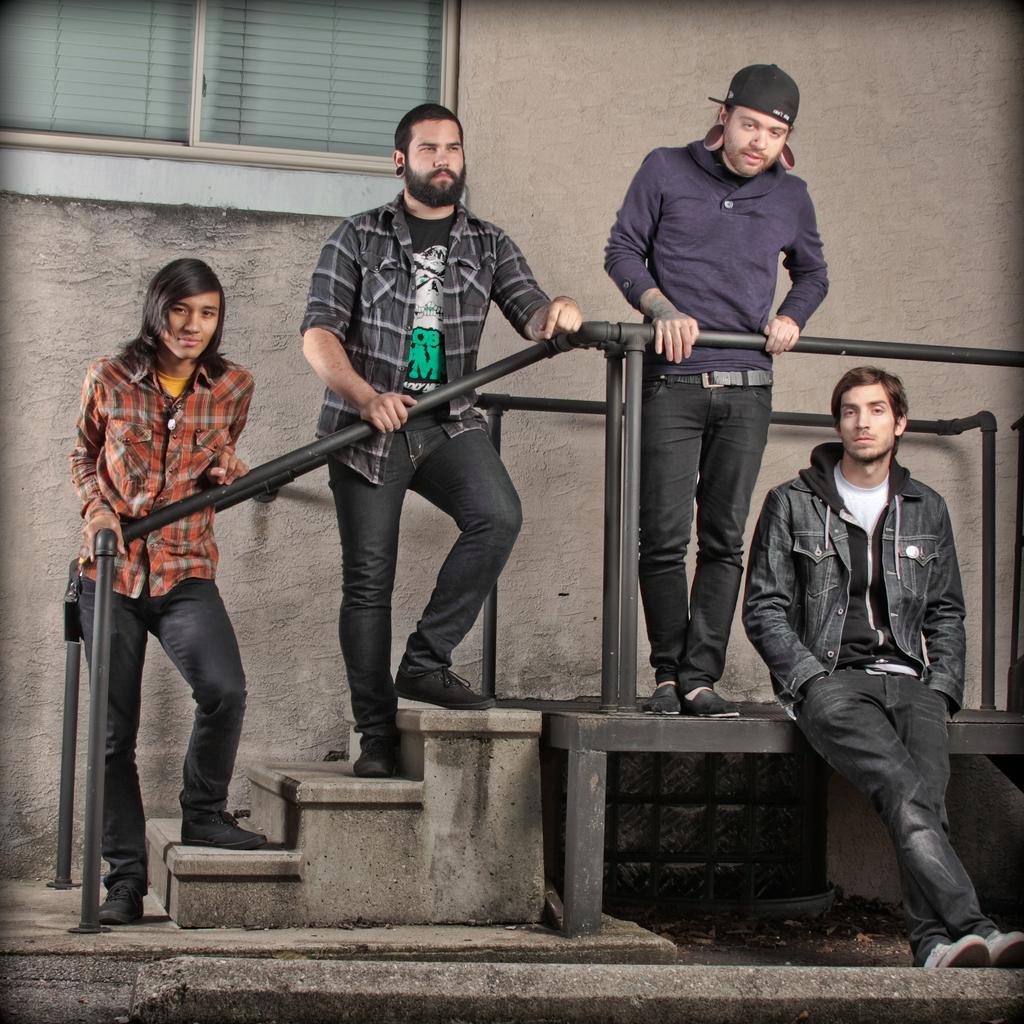Please provide a concise description of this image. In this image I can see three people are standing on the stairs and one person is sitting. Back I can see building and glass windows. They are wearing different color dress. 